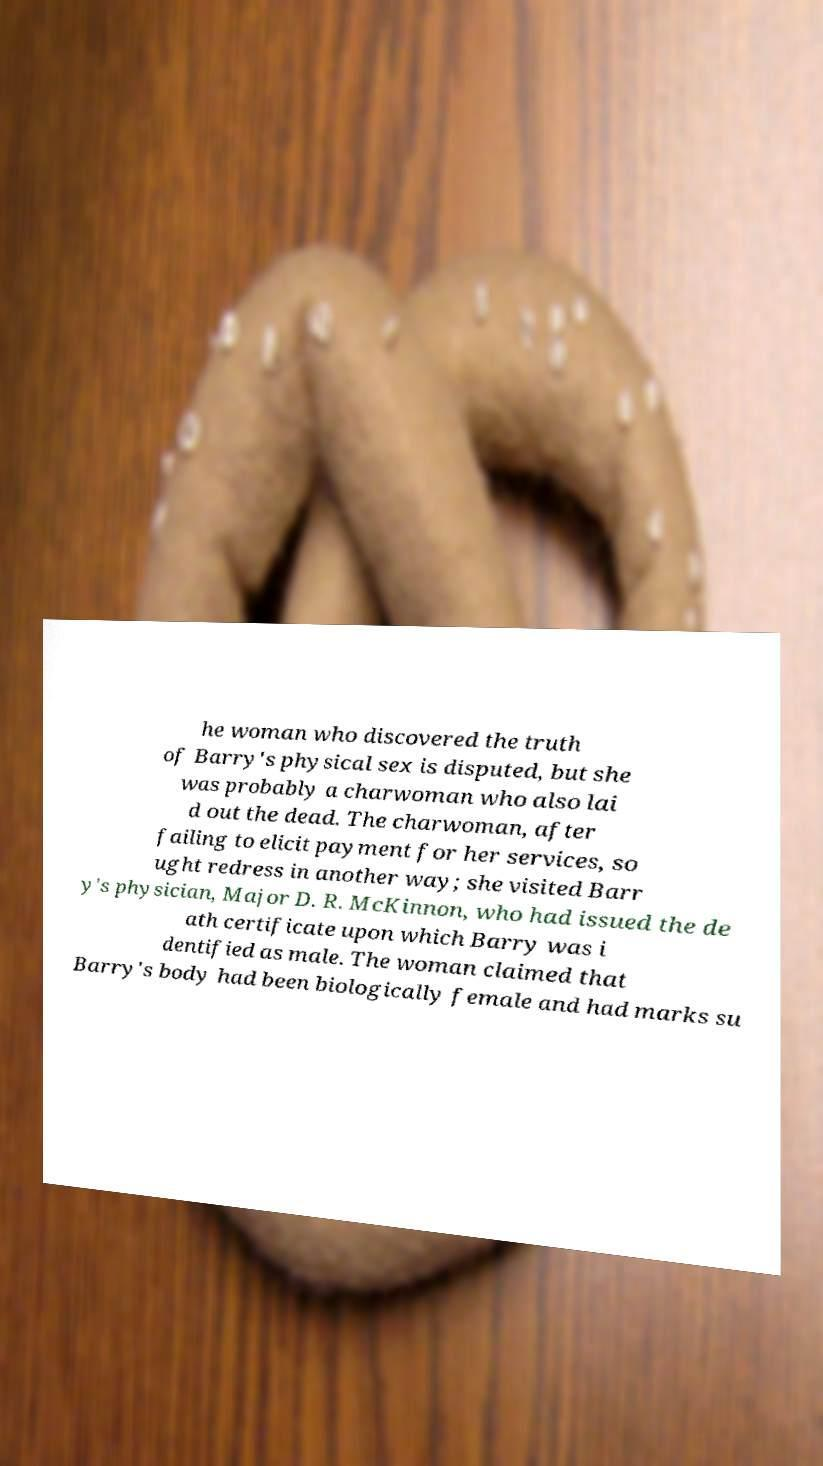For documentation purposes, I need the text within this image transcribed. Could you provide that? he woman who discovered the truth of Barry's physical sex is disputed, but she was probably a charwoman who also lai d out the dead. The charwoman, after failing to elicit payment for her services, so ught redress in another way; she visited Barr y's physician, Major D. R. McKinnon, who had issued the de ath certificate upon which Barry was i dentified as male. The woman claimed that Barry's body had been biologically female and had marks su 